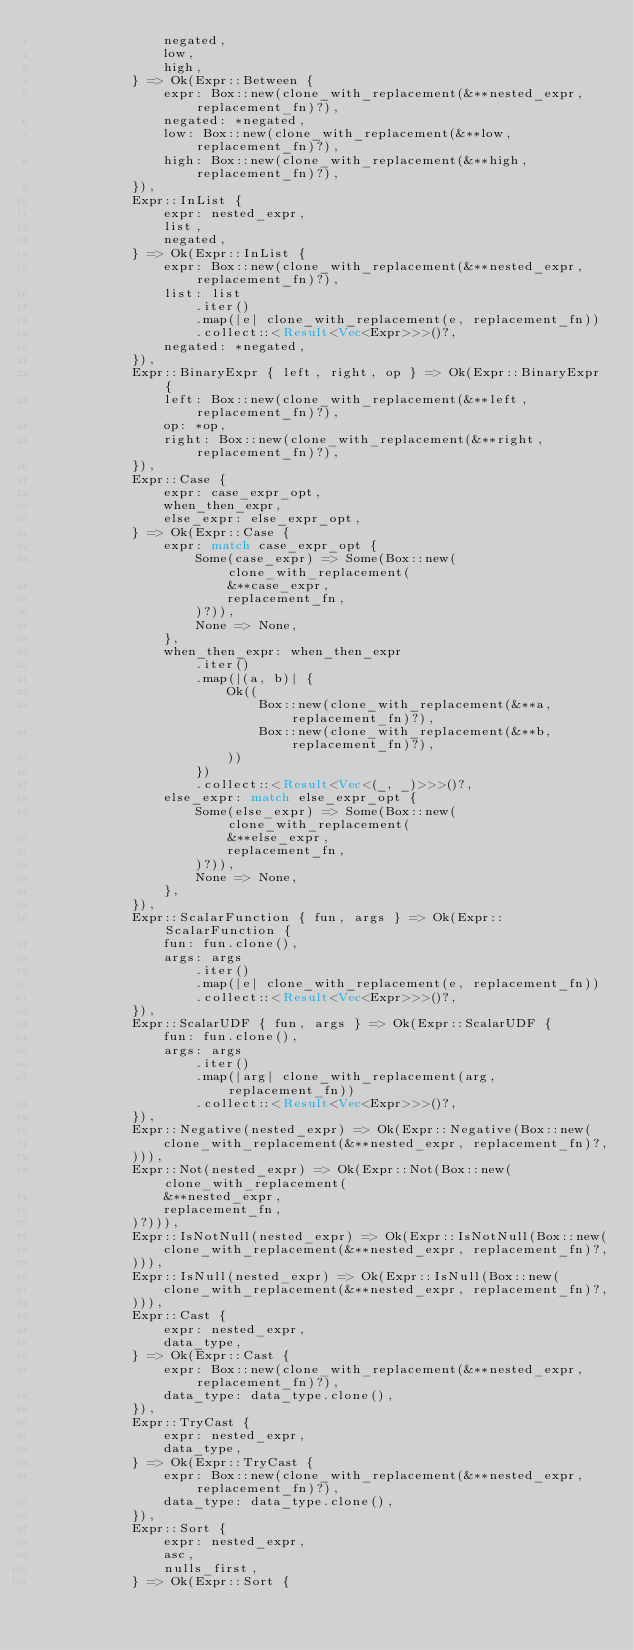<code> <loc_0><loc_0><loc_500><loc_500><_Rust_>                negated,
                low,
                high,
            } => Ok(Expr::Between {
                expr: Box::new(clone_with_replacement(&**nested_expr, replacement_fn)?),
                negated: *negated,
                low: Box::new(clone_with_replacement(&**low, replacement_fn)?),
                high: Box::new(clone_with_replacement(&**high, replacement_fn)?),
            }),
            Expr::InList {
                expr: nested_expr,
                list,
                negated,
            } => Ok(Expr::InList {
                expr: Box::new(clone_with_replacement(&**nested_expr, replacement_fn)?),
                list: list
                    .iter()
                    .map(|e| clone_with_replacement(e, replacement_fn))
                    .collect::<Result<Vec<Expr>>>()?,
                negated: *negated,
            }),
            Expr::BinaryExpr { left, right, op } => Ok(Expr::BinaryExpr {
                left: Box::new(clone_with_replacement(&**left, replacement_fn)?),
                op: *op,
                right: Box::new(clone_with_replacement(&**right, replacement_fn)?),
            }),
            Expr::Case {
                expr: case_expr_opt,
                when_then_expr,
                else_expr: else_expr_opt,
            } => Ok(Expr::Case {
                expr: match case_expr_opt {
                    Some(case_expr) => Some(Box::new(clone_with_replacement(
                        &**case_expr,
                        replacement_fn,
                    )?)),
                    None => None,
                },
                when_then_expr: when_then_expr
                    .iter()
                    .map(|(a, b)| {
                        Ok((
                            Box::new(clone_with_replacement(&**a, replacement_fn)?),
                            Box::new(clone_with_replacement(&**b, replacement_fn)?),
                        ))
                    })
                    .collect::<Result<Vec<(_, _)>>>()?,
                else_expr: match else_expr_opt {
                    Some(else_expr) => Some(Box::new(clone_with_replacement(
                        &**else_expr,
                        replacement_fn,
                    )?)),
                    None => None,
                },
            }),
            Expr::ScalarFunction { fun, args } => Ok(Expr::ScalarFunction {
                fun: fun.clone(),
                args: args
                    .iter()
                    .map(|e| clone_with_replacement(e, replacement_fn))
                    .collect::<Result<Vec<Expr>>>()?,
            }),
            Expr::ScalarUDF { fun, args } => Ok(Expr::ScalarUDF {
                fun: fun.clone(),
                args: args
                    .iter()
                    .map(|arg| clone_with_replacement(arg, replacement_fn))
                    .collect::<Result<Vec<Expr>>>()?,
            }),
            Expr::Negative(nested_expr) => Ok(Expr::Negative(Box::new(
                clone_with_replacement(&**nested_expr, replacement_fn)?,
            ))),
            Expr::Not(nested_expr) => Ok(Expr::Not(Box::new(clone_with_replacement(
                &**nested_expr,
                replacement_fn,
            )?))),
            Expr::IsNotNull(nested_expr) => Ok(Expr::IsNotNull(Box::new(
                clone_with_replacement(&**nested_expr, replacement_fn)?,
            ))),
            Expr::IsNull(nested_expr) => Ok(Expr::IsNull(Box::new(
                clone_with_replacement(&**nested_expr, replacement_fn)?,
            ))),
            Expr::Cast {
                expr: nested_expr,
                data_type,
            } => Ok(Expr::Cast {
                expr: Box::new(clone_with_replacement(&**nested_expr, replacement_fn)?),
                data_type: data_type.clone(),
            }),
            Expr::TryCast {
                expr: nested_expr,
                data_type,
            } => Ok(Expr::TryCast {
                expr: Box::new(clone_with_replacement(&**nested_expr, replacement_fn)?),
                data_type: data_type.clone(),
            }),
            Expr::Sort {
                expr: nested_expr,
                asc,
                nulls_first,
            } => Ok(Expr::Sort {</code> 